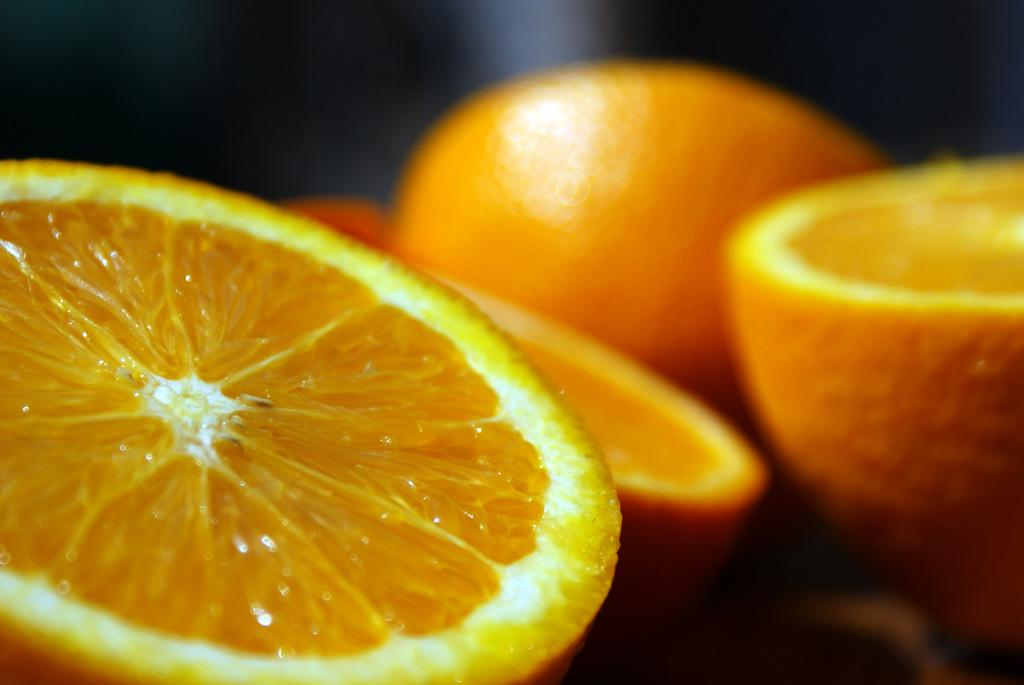What type of fruit is visible in the image? There are orange pieces in the image. How many pieces of orange can be seen in the image? The orange is cut into two pieces. What type of glass is being used to perform an operation on the orange in the image? There is no glass or operation present in the image; it simply shows two pieces of orange. 